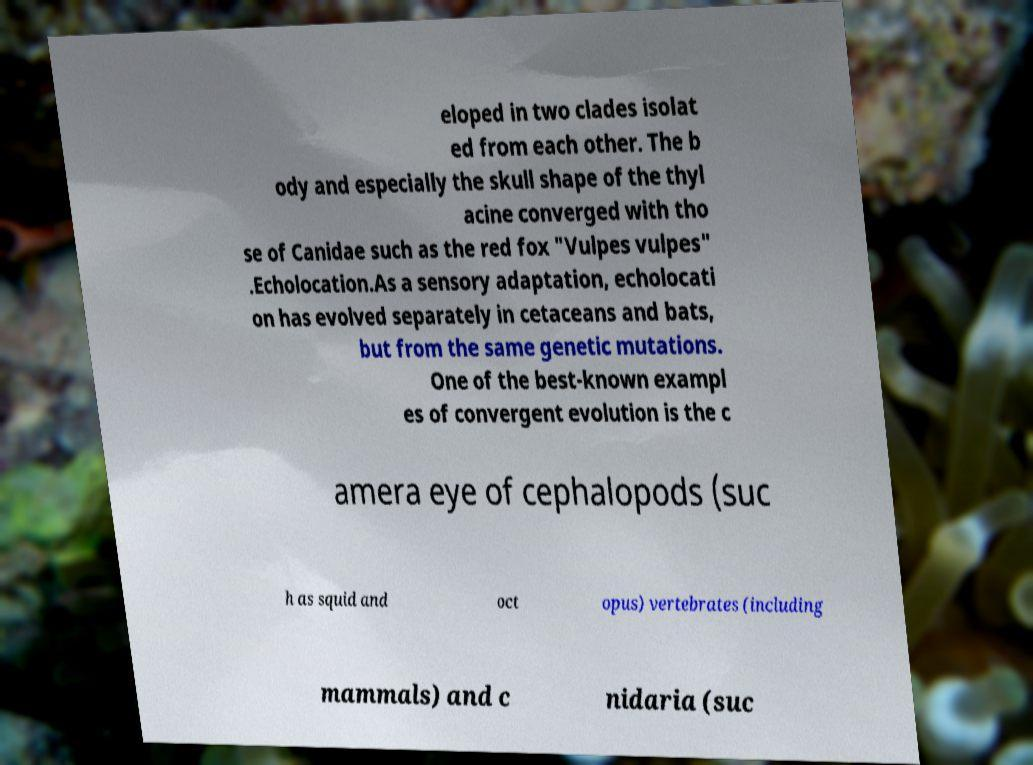Can you read and provide the text displayed in the image?This photo seems to have some interesting text. Can you extract and type it out for me? eloped in two clades isolat ed from each other. The b ody and especially the skull shape of the thyl acine converged with tho se of Canidae such as the red fox "Vulpes vulpes" .Echolocation.As a sensory adaptation, echolocati on has evolved separately in cetaceans and bats, but from the same genetic mutations. One of the best-known exampl es of convergent evolution is the c amera eye of cephalopods (suc h as squid and oct opus) vertebrates (including mammals) and c nidaria (suc 